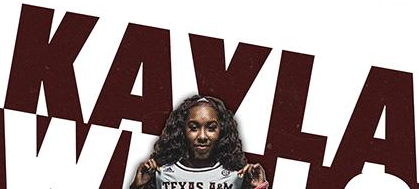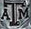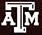What text is displayed in these images sequentially, separated by a semicolon? KAVLA; ATM; ATM 